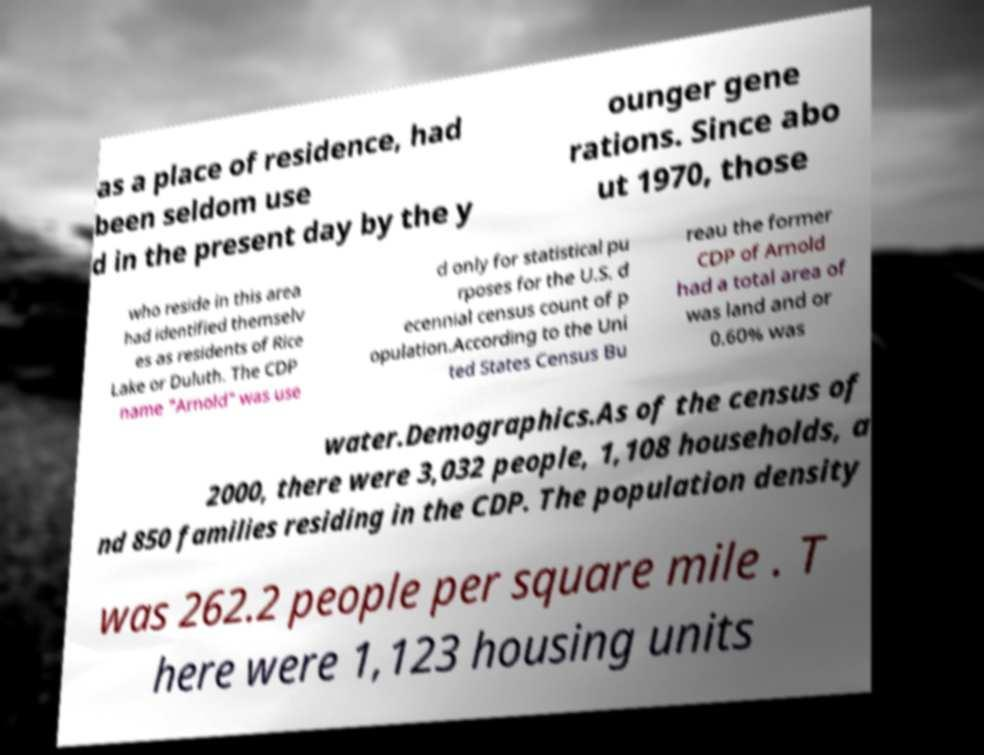Please identify and transcribe the text found in this image. as a place of residence, had been seldom use d in the present day by the y ounger gene rations. Since abo ut 1970, those who reside in this area had identified themselv es as residents of Rice Lake or Duluth. The CDP name "Arnold" was use d only for statistical pu rposes for the U.S. d ecennial census count of p opulation.According to the Uni ted States Census Bu reau the former CDP of Arnold had a total area of was land and or 0.60% was water.Demographics.As of the census of 2000, there were 3,032 people, 1,108 households, a nd 850 families residing in the CDP. The population density was 262.2 people per square mile . T here were 1,123 housing units 